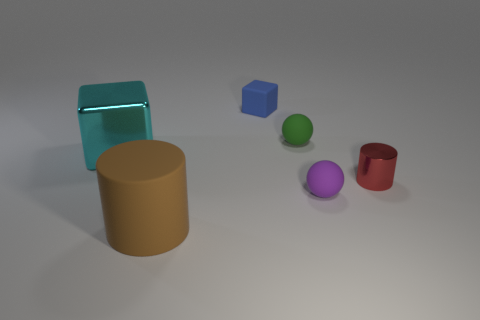Add 4 small cyan spheres. How many objects exist? 10 Subtract all balls. How many objects are left? 4 Add 5 green balls. How many green balls are left? 6 Add 5 cyan cubes. How many cyan cubes exist? 6 Subtract 0 yellow cubes. How many objects are left? 6 Subtract all metal cubes. Subtract all large shiny things. How many objects are left? 4 